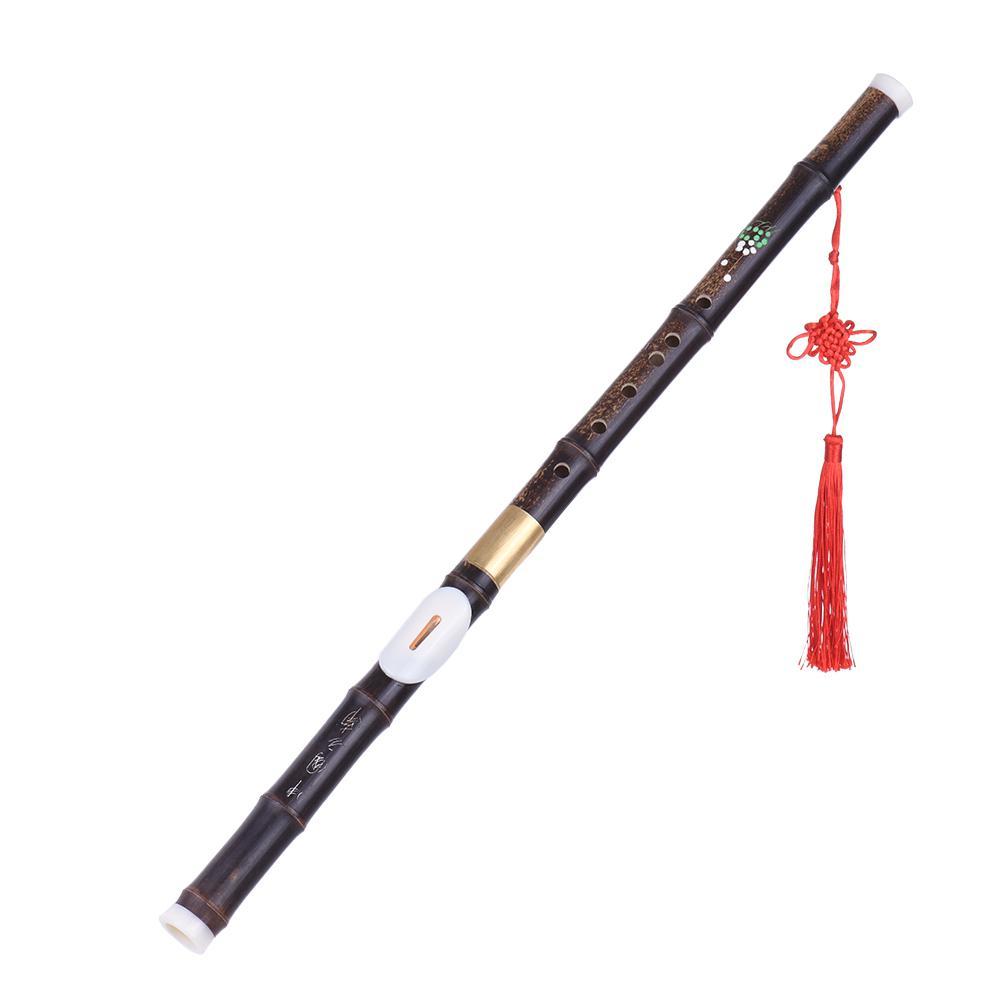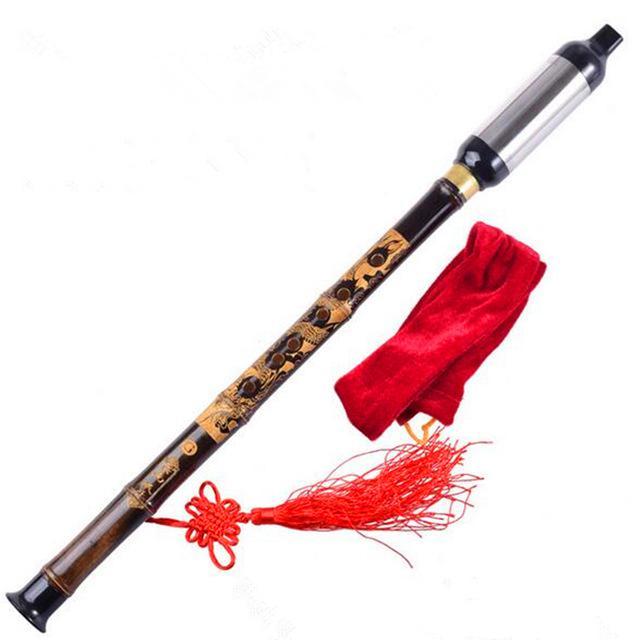The first image is the image on the left, the second image is the image on the right. Assess this claim about the two images: "there is a flute with a red tassel hanging from the lower half and a soft fabric pouch next to it". Correct or not? Answer yes or no. Yes. 